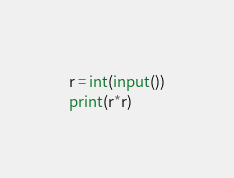<code> <loc_0><loc_0><loc_500><loc_500><_Python_>r = int(input())
print(r*r)</code> 